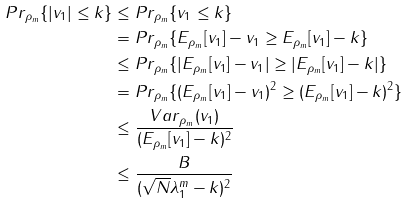Convert formula to latex. <formula><loc_0><loc_0><loc_500><loc_500>P r _ { \rho _ { m } } \{ | v _ { 1 } | \leq k \} & \leq P r _ { \rho _ { m } } \{ v _ { 1 } \leq k \} \\ & = P r _ { \rho _ { m } } \{ E _ { \rho _ { m } } [ v _ { 1 } ] - v _ { 1 } \geq E _ { \rho _ { m } } [ v _ { 1 } ] - k \} \\ & \leq P r _ { \rho _ { m } } \{ | E _ { \rho _ { m } } [ v _ { 1 } ] - v _ { 1 } | \geq | E _ { \rho _ { m } } [ v _ { 1 } ] - k | \} \\ & = P r _ { \rho _ { m } } \{ ( E _ { \rho _ { m } } [ v _ { 1 } ] - v _ { 1 } ) ^ { 2 } \geq ( E _ { \rho _ { m } } [ v _ { 1 } ] - k ) ^ { 2 } \} \\ & \leq \frac { V a r _ { \rho _ { m } } ( v _ { 1 } ) } { ( E _ { \rho _ { m } } [ v _ { 1 } ] - k ) ^ { 2 } } \\ & \leq \frac { B } { ( \sqrt { N } \lambda _ { 1 } ^ { m } - k ) ^ { 2 } }</formula> 